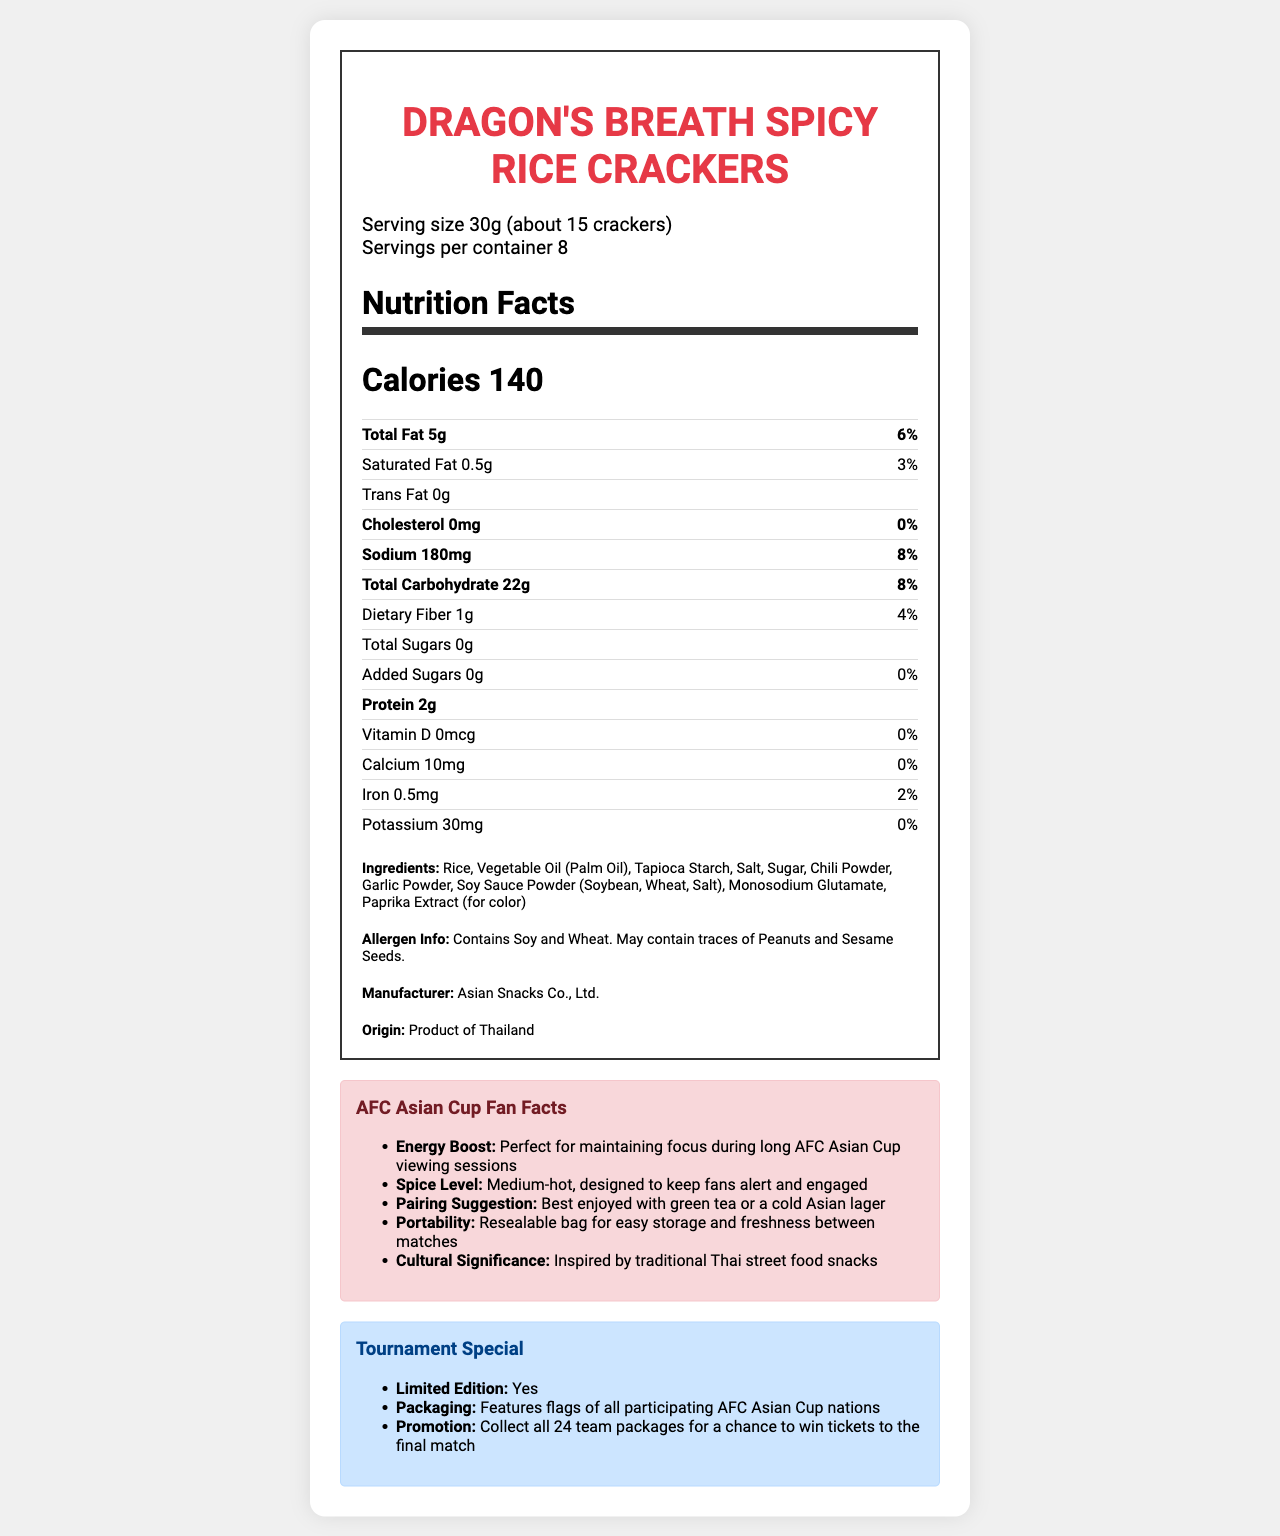what is the serving size? The document states that the serving size is 30g, which is approximately 15 crackers.
Answer: 30g (about 15 crackers) how many servings are in a container? According to the document, there are 8 servings per container.
Answer: 8 what is the calorie count per serving? The document shows that each serving contains 140 calories.
Answer: 140 how much sodium is in one serving? The sodium content per serving is listed as 180mg in the document.
Answer: 180mg what allergens are present in the product? The document provides an allergen information section which states the allergens present.
Answer: Contains Soy and Wheat. May contain traces of Peanuts and Sesame Seeds. what type of oil is used in the crackers? The ingredients list includes Vegetable Oil (Palm Oil).
Answer: Vegetable Oil (Palm Oil) what is the total carbohydrate content per serving? The nutrition facts section indicates that the total carbohydrate content per serving is 22g.
Answer: 22g what is the protein content in one serving? The document lists the protein content per serving as 2g.
Answer: 2g which vitamin is not present in the crackers? The document shows that the crackers contain no Vitamin D.
Answer: Vitamin D where is the product manufactured? The document states that the origin of the product is Thailand.
Answer: Thailand how much dietary fiber does the product contain per serving? The dietary fiber content per serving is 1g according to the document.
Answer: 1g how much added sugar is in one serving? The document shows that there is no added sugar in one serving.
Answer: 0g who manufactures the crackers? The manufacturer listed in the document is Asian Snacks Co., Ltd.
Answer: Asian Snacks Co., Ltd. what is the Limited Edition feature of the product related to? A. Special ingredients B. New flavor C. Packaging design D. Promotion The document states that the Limited Edition feature includes packaging that features flags of all participating AFC Asian Cup nations.
Answer: C what is the promotional offer for fans? A. Free green tea B. Collect all 24 team packages for a chance to win tickets to the final match C. Free snack samples D. Discount on next purchase The document details a promotion where fans can collect all 24 team packages for a chance to win tickets to the final match.
Answer: B how much iron is present in one serving? A. 0mg B. 0.5mg C. 10mg D. 30mg The iron content per serving is listed as 0.5mg.
Answer: B does the product contain any cholesterol? The document indicates that the product contains 0mg of cholesterol.
Answer: No what is the main idea of the document? The document outlines the nutritional facts, ingredients, and allergen information for a snack product while also highlighting its fan-centric features related to the AFC Asian Cup.
Answer: It provides nutritional information, ingredients, allergen details, and fan-related features of Dragon's Breath Spicy Rice Crackers, targeted at AFC Asian Cup viewers. how many calories are in two servings? The number of calories in two servings is not explicitly stated in the document. While it can be inferred, it's not directly answerable based on the given information.
Answer: Cannot be determined 